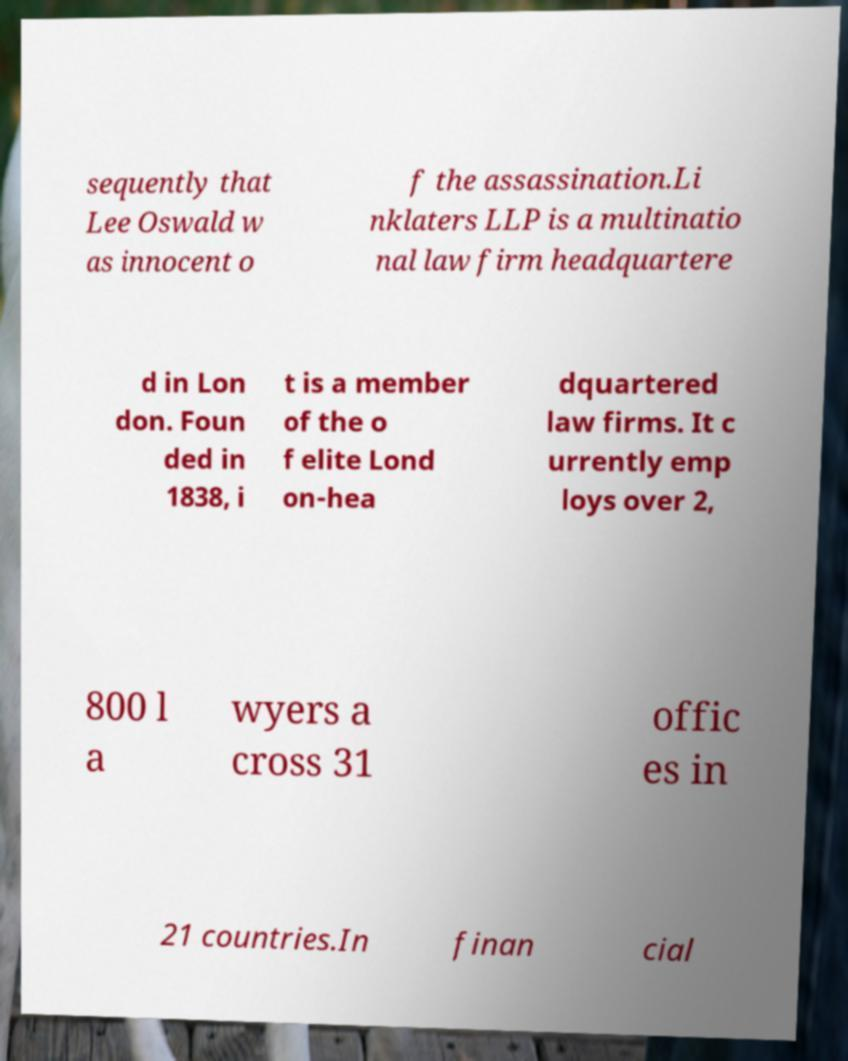What messages or text are displayed in this image? I need them in a readable, typed format. sequently that Lee Oswald w as innocent o f the assassination.Li nklaters LLP is a multinatio nal law firm headquartere d in Lon don. Foun ded in 1838, i t is a member of the o f elite Lond on-hea dquartered law firms. It c urrently emp loys over 2, 800 l a wyers a cross 31 offic es in 21 countries.In finan cial 